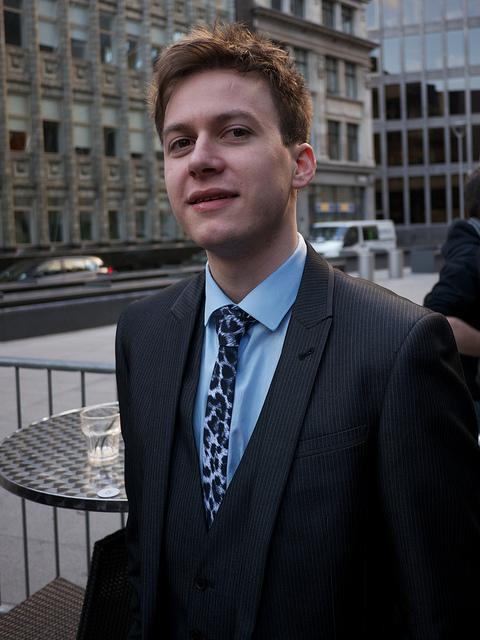Is the gentleman wearing glasses?
Answer briefly. No. How many cars are there in the picture?
Quick response, please. 2. What color is the man's tie?
Quick response, please. Black and white. Is he clean shaven?
Be succinct. Yes. Is the man's suit coat?
Be succinct. Yes. Do they work for the same company?
Give a very brief answer. No. What is the race of the man?
Answer briefly. White. How many glasses are sitting on the table?
Be succinct. 1. What color is his tie?
Keep it brief. Blue. 